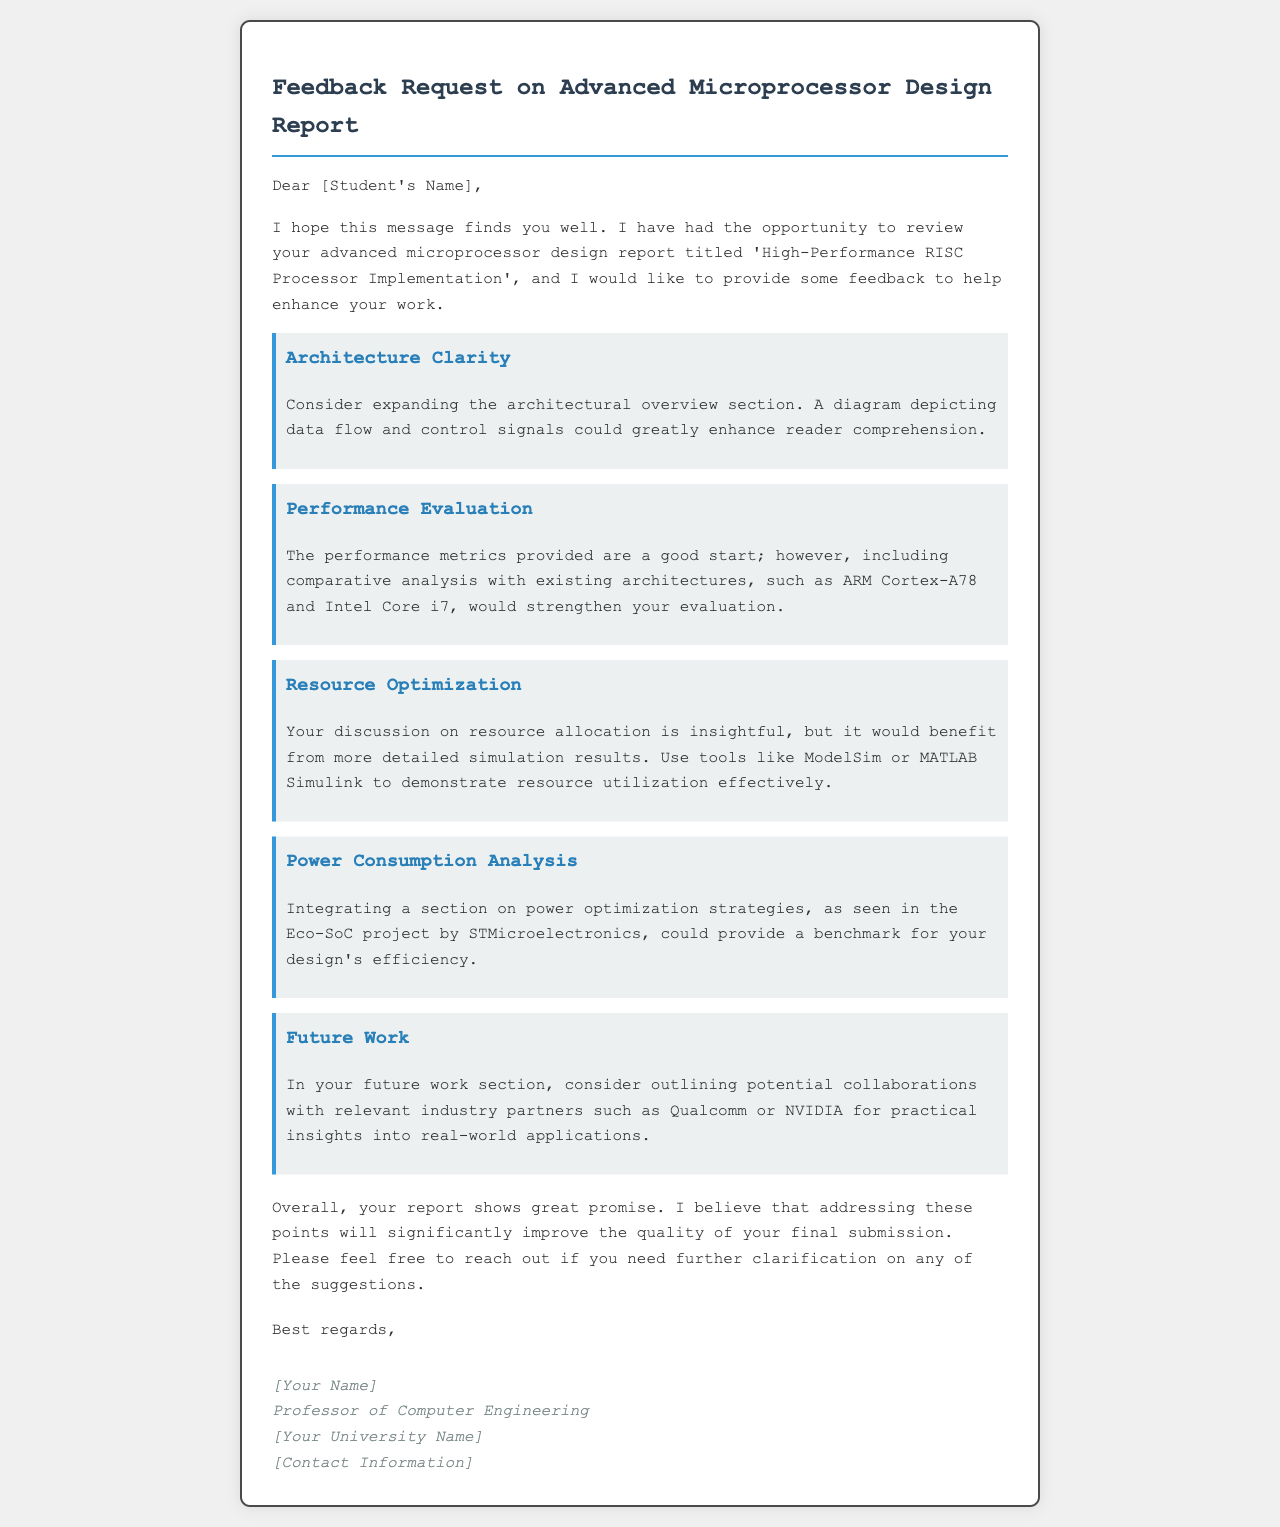What is the title of the student’s report? The title of the report is mentioned at the beginning of the email as 'High-Performance RISC Processor Implementation'.
Answer: High-Performance RISC Processor Implementation What is one suggestion for improving the architecture clarity? The suggestion given includes expanding the architectural overview section and including a diagram.
Answer: Diagram depicting data flow and control signals Which existing architectures are suggested for comparative analysis? The email mentions ARM Cortex-A78 and Intel Core i7 for comparison in performance evaluation.
Answer: ARM Cortex-A78 and Intel Core i7 What tool is recommended for demonstrating resource utilization effectively? The document suggests using tools like ModelSim or MATLAB Simulink for this purpose.
Answer: ModelSim or MATLAB Simulink Who is the author of the email? The author of the email is indicated by the placeholder [Your Name].
Answer: [Your Name] What potential industry partners are mentioned for future work collaboration? The email mentions Qualcomm or NVIDIA as potential collaborators for practical insights.
Answer: Qualcomm or NVIDIA What overall impression does the professor have of the report? The professor expresses that the report shows great promise and states that addressing the points will improve the submission quality.
Answer: Great promise How does the professor sign off the email? The email's closing line mentions "Best regards".
Answer: Best regards What type of analysis does the professor suggest adding regarding power consumption? The professor suggests integrating a section on power optimization strategies.
Answer: Power optimization strategies 